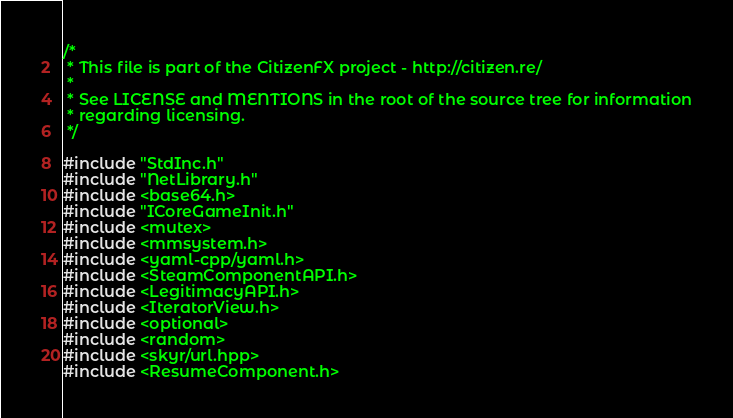<code> <loc_0><loc_0><loc_500><loc_500><_C++_>/*
 * This file is part of the CitizenFX project - http://citizen.re/
 *
 * See LICENSE and MENTIONS in the root of the source tree for information
 * regarding licensing.
 */

#include "StdInc.h"
#include "NetLibrary.h"
#include <base64.h>
#include "ICoreGameInit.h"
#include <mutex>
#include <mmsystem.h>
#include <yaml-cpp/yaml.h>
#include <SteamComponentAPI.h>
#include <LegitimacyAPI.h>
#include <IteratorView.h>
#include <optional>
#include <random>
#include <skyr/url.hpp>
#include <ResumeComponent.h></code> 